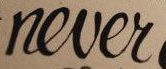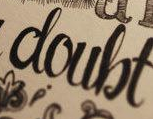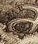What text appears in these images from left to right, separated by a semicolon? never; doubt; a 